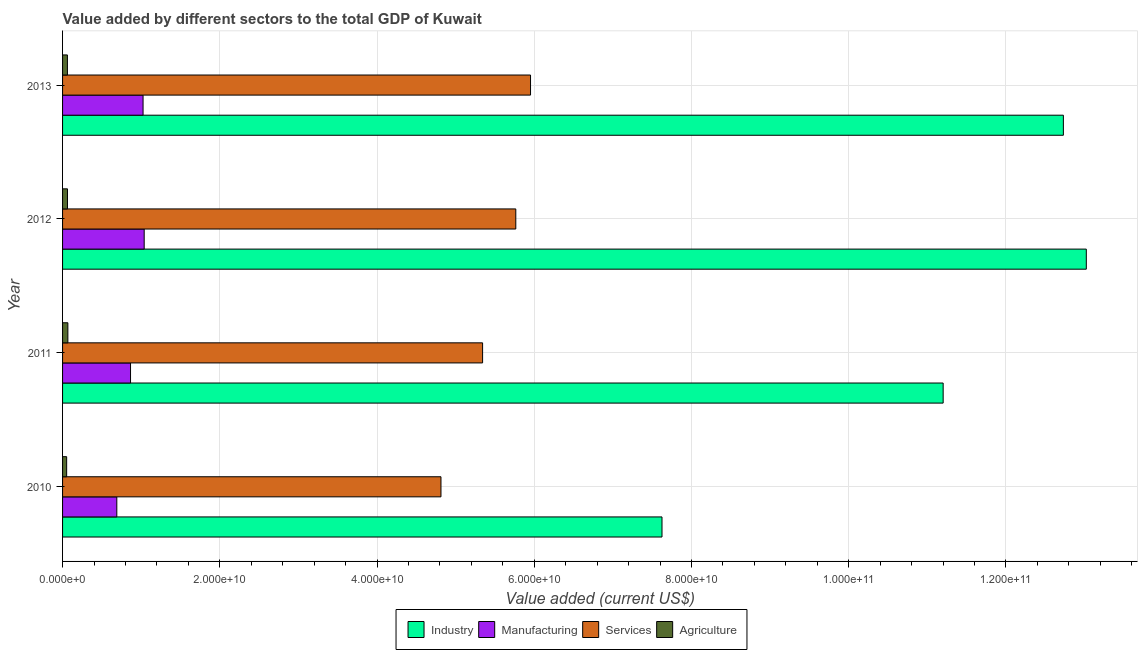How many bars are there on the 4th tick from the top?
Keep it short and to the point. 4. In how many cases, is the number of bars for a given year not equal to the number of legend labels?
Give a very brief answer. 0. What is the value added by manufacturing sector in 2011?
Keep it short and to the point. 8.65e+09. Across all years, what is the maximum value added by services sector?
Provide a succinct answer. 5.95e+1. Across all years, what is the minimum value added by agricultural sector?
Ensure brevity in your answer.  5.21e+08. In which year was the value added by industrial sector minimum?
Give a very brief answer. 2010. What is the total value added by industrial sector in the graph?
Your answer should be compact. 4.46e+11. What is the difference between the value added by manufacturing sector in 2011 and that in 2012?
Your answer should be very brief. -1.74e+09. What is the difference between the value added by industrial sector in 2010 and the value added by manufacturing sector in 2011?
Keep it short and to the point. 6.76e+1. What is the average value added by industrial sector per year?
Keep it short and to the point. 1.11e+11. In the year 2011, what is the difference between the value added by manufacturing sector and value added by agricultural sector?
Make the answer very short. 7.97e+09. What is the ratio of the value added by services sector in 2010 to that in 2011?
Provide a short and direct response. 0.9. Is the difference between the value added by services sector in 2010 and 2011 greater than the difference between the value added by agricultural sector in 2010 and 2011?
Your answer should be very brief. No. What is the difference between the highest and the second highest value added by manufacturing sector?
Offer a very short reply. 1.42e+08. What is the difference between the highest and the lowest value added by services sector?
Offer a terse response. 1.14e+1. In how many years, is the value added by agricultural sector greater than the average value added by agricultural sector taken over all years?
Your answer should be very brief. 3. Is the sum of the value added by manufacturing sector in 2010 and 2012 greater than the maximum value added by industrial sector across all years?
Give a very brief answer. No. Is it the case that in every year, the sum of the value added by services sector and value added by manufacturing sector is greater than the sum of value added by industrial sector and value added by agricultural sector?
Your answer should be compact. Yes. What does the 1st bar from the top in 2012 represents?
Your answer should be very brief. Agriculture. What does the 2nd bar from the bottom in 2013 represents?
Ensure brevity in your answer.  Manufacturing. Is it the case that in every year, the sum of the value added by industrial sector and value added by manufacturing sector is greater than the value added by services sector?
Give a very brief answer. Yes. Are all the bars in the graph horizontal?
Provide a succinct answer. Yes. How many years are there in the graph?
Ensure brevity in your answer.  4. What is the difference between two consecutive major ticks on the X-axis?
Provide a succinct answer. 2.00e+1. Are the values on the major ticks of X-axis written in scientific E-notation?
Offer a terse response. Yes. Where does the legend appear in the graph?
Keep it short and to the point. Bottom center. How many legend labels are there?
Your response must be concise. 4. How are the legend labels stacked?
Give a very brief answer. Horizontal. What is the title of the graph?
Give a very brief answer. Value added by different sectors to the total GDP of Kuwait. What is the label or title of the X-axis?
Ensure brevity in your answer.  Value added (current US$). What is the Value added (current US$) of Industry in 2010?
Your answer should be very brief. 7.63e+1. What is the Value added (current US$) in Manufacturing in 2010?
Your answer should be compact. 6.90e+09. What is the Value added (current US$) in Services in 2010?
Offer a terse response. 4.81e+1. What is the Value added (current US$) of Agriculture in 2010?
Your answer should be very brief. 5.21e+08. What is the Value added (current US$) in Industry in 2011?
Make the answer very short. 1.12e+11. What is the Value added (current US$) of Manufacturing in 2011?
Your answer should be very brief. 8.65e+09. What is the Value added (current US$) of Services in 2011?
Keep it short and to the point. 5.34e+1. What is the Value added (current US$) of Agriculture in 2011?
Offer a very short reply. 6.76e+08. What is the Value added (current US$) of Industry in 2012?
Give a very brief answer. 1.30e+11. What is the Value added (current US$) of Manufacturing in 2012?
Give a very brief answer. 1.04e+1. What is the Value added (current US$) of Services in 2012?
Give a very brief answer. 5.77e+1. What is the Value added (current US$) of Agriculture in 2012?
Make the answer very short. 6.26e+08. What is the Value added (current US$) in Industry in 2013?
Keep it short and to the point. 1.27e+11. What is the Value added (current US$) of Manufacturing in 2013?
Ensure brevity in your answer.  1.02e+1. What is the Value added (current US$) of Services in 2013?
Make the answer very short. 5.95e+1. What is the Value added (current US$) in Agriculture in 2013?
Ensure brevity in your answer.  6.18e+08. Across all years, what is the maximum Value added (current US$) in Industry?
Your answer should be compact. 1.30e+11. Across all years, what is the maximum Value added (current US$) in Manufacturing?
Provide a short and direct response. 1.04e+1. Across all years, what is the maximum Value added (current US$) of Services?
Your answer should be compact. 5.95e+1. Across all years, what is the maximum Value added (current US$) in Agriculture?
Offer a terse response. 6.76e+08. Across all years, what is the minimum Value added (current US$) of Industry?
Your answer should be compact. 7.63e+1. Across all years, what is the minimum Value added (current US$) in Manufacturing?
Offer a terse response. 6.90e+09. Across all years, what is the minimum Value added (current US$) of Services?
Offer a very short reply. 4.81e+1. Across all years, what is the minimum Value added (current US$) of Agriculture?
Keep it short and to the point. 5.21e+08. What is the total Value added (current US$) in Industry in the graph?
Give a very brief answer. 4.46e+11. What is the total Value added (current US$) in Manufacturing in the graph?
Provide a short and direct response. 3.62e+1. What is the total Value added (current US$) in Services in the graph?
Your answer should be very brief. 2.19e+11. What is the total Value added (current US$) in Agriculture in the graph?
Your answer should be compact. 2.44e+09. What is the difference between the Value added (current US$) of Industry in 2010 and that in 2011?
Your answer should be very brief. -3.58e+1. What is the difference between the Value added (current US$) of Manufacturing in 2010 and that in 2011?
Ensure brevity in your answer.  -1.75e+09. What is the difference between the Value added (current US$) of Services in 2010 and that in 2011?
Give a very brief answer. -5.29e+09. What is the difference between the Value added (current US$) in Agriculture in 2010 and that in 2011?
Provide a short and direct response. -1.55e+08. What is the difference between the Value added (current US$) of Industry in 2010 and that in 2012?
Provide a short and direct response. -5.40e+1. What is the difference between the Value added (current US$) of Manufacturing in 2010 and that in 2012?
Make the answer very short. -3.48e+09. What is the difference between the Value added (current US$) of Services in 2010 and that in 2012?
Your answer should be very brief. -9.52e+09. What is the difference between the Value added (current US$) of Agriculture in 2010 and that in 2012?
Ensure brevity in your answer.  -1.05e+08. What is the difference between the Value added (current US$) in Industry in 2010 and that in 2013?
Keep it short and to the point. -5.11e+1. What is the difference between the Value added (current US$) of Manufacturing in 2010 and that in 2013?
Your answer should be compact. -3.34e+09. What is the difference between the Value added (current US$) in Services in 2010 and that in 2013?
Offer a very short reply. -1.14e+1. What is the difference between the Value added (current US$) of Agriculture in 2010 and that in 2013?
Offer a terse response. -9.72e+07. What is the difference between the Value added (current US$) of Industry in 2011 and that in 2012?
Ensure brevity in your answer.  -1.82e+1. What is the difference between the Value added (current US$) of Manufacturing in 2011 and that in 2012?
Provide a short and direct response. -1.74e+09. What is the difference between the Value added (current US$) in Services in 2011 and that in 2012?
Your answer should be compact. -4.22e+09. What is the difference between the Value added (current US$) of Agriculture in 2011 and that in 2012?
Your response must be concise. 4.98e+07. What is the difference between the Value added (current US$) in Industry in 2011 and that in 2013?
Your response must be concise. -1.53e+1. What is the difference between the Value added (current US$) of Manufacturing in 2011 and that in 2013?
Make the answer very short. -1.59e+09. What is the difference between the Value added (current US$) of Services in 2011 and that in 2013?
Provide a succinct answer. -6.10e+09. What is the difference between the Value added (current US$) of Agriculture in 2011 and that in 2013?
Your response must be concise. 5.76e+07. What is the difference between the Value added (current US$) of Industry in 2012 and that in 2013?
Keep it short and to the point. 2.92e+09. What is the difference between the Value added (current US$) in Manufacturing in 2012 and that in 2013?
Make the answer very short. 1.42e+08. What is the difference between the Value added (current US$) of Services in 2012 and that in 2013?
Offer a very short reply. -1.87e+09. What is the difference between the Value added (current US$) in Agriculture in 2012 and that in 2013?
Offer a very short reply. 7.82e+06. What is the difference between the Value added (current US$) of Industry in 2010 and the Value added (current US$) of Manufacturing in 2011?
Make the answer very short. 6.76e+1. What is the difference between the Value added (current US$) in Industry in 2010 and the Value added (current US$) in Services in 2011?
Ensure brevity in your answer.  2.28e+1. What is the difference between the Value added (current US$) in Industry in 2010 and the Value added (current US$) in Agriculture in 2011?
Your answer should be very brief. 7.56e+1. What is the difference between the Value added (current US$) in Manufacturing in 2010 and the Value added (current US$) in Services in 2011?
Offer a very short reply. -4.65e+1. What is the difference between the Value added (current US$) of Manufacturing in 2010 and the Value added (current US$) of Agriculture in 2011?
Offer a terse response. 6.22e+09. What is the difference between the Value added (current US$) in Services in 2010 and the Value added (current US$) in Agriculture in 2011?
Give a very brief answer. 4.75e+1. What is the difference between the Value added (current US$) in Industry in 2010 and the Value added (current US$) in Manufacturing in 2012?
Your answer should be compact. 6.59e+1. What is the difference between the Value added (current US$) in Industry in 2010 and the Value added (current US$) in Services in 2012?
Make the answer very short. 1.86e+1. What is the difference between the Value added (current US$) in Industry in 2010 and the Value added (current US$) in Agriculture in 2012?
Your response must be concise. 7.56e+1. What is the difference between the Value added (current US$) of Manufacturing in 2010 and the Value added (current US$) of Services in 2012?
Your answer should be very brief. -5.08e+1. What is the difference between the Value added (current US$) in Manufacturing in 2010 and the Value added (current US$) in Agriculture in 2012?
Make the answer very short. 6.27e+09. What is the difference between the Value added (current US$) in Services in 2010 and the Value added (current US$) in Agriculture in 2012?
Keep it short and to the point. 4.75e+1. What is the difference between the Value added (current US$) in Industry in 2010 and the Value added (current US$) in Manufacturing in 2013?
Your answer should be compact. 6.60e+1. What is the difference between the Value added (current US$) in Industry in 2010 and the Value added (current US$) in Services in 2013?
Offer a very short reply. 1.67e+1. What is the difference between the Value added (current US$) of Industry in 2010 and the Value added (current US$) of Agriculture in 2013?
Make the answer very short. 7.56e+1. What is the difference between the Value added (current US$) in Manufacturing in 2010 and the Value added (current US$) in Services in 2013?
Offer a terse response. -5.26e+1. What is the difference between the Value added (current US$) of Manufacturing in 2010 and the Value added (current US$) of Agriculture in 2013?
Provide a succinct answer. 6.28e+09. What is the difference between the Value added (current US$) in Services in 2010 and the Value added (current US$) in Agriculture in 2013?
Ensure brevity in your answer.  4.75e+1. What is the difference between the Value added (current US$) of Industry in 2011 and the Value added (current US$) of Manufacturing in 2012?
Your response must be concise. 1.02e+11. What is the difference between the Value added (current US$) of Industry in 2011 and the Value added (current US$) of Services in 2012?
Offer a very short reply. 5.44e+1. What is the difference between the Value added (current US$) in Industry in 2011 and the Value added (current US$) in Agriculture in 2012?
Keep it short and to the point. 1.11e+11. What is the difference between the Value added (current US$) of Manufacturing in 2011 and the Value added (current US$) of Services in 2012?
Keep it short and to the point. -4.90e+1. What is the difference between the Value added (current US$) of Manufacturing in 2011 and the Value added (current US$) of Agriculture in 2012?
Provide a succinct answer. 8.02e+09. What is the difference between the Value added (current US$) in Services in 2011 and the Value added (current US$) in Agriculture in 2012?
Your response must be concise. 5.28e+1. What is the difference between the Value added (current US$) of Industry in 2011 and the Value added (current US$) of Manufacturing in 2013?
Ensure brevity in your answer.  1.02e+11. What is the difference between the Value added (current US$) of Industry in 2011 and the Value added (current US$) of Services in 2013?
Offer a very short reply. 5.25e+1. What is the difference between the Value added (current US$) of Industry in 2011 and the Value added (current US$) of Agriculture in 2013?
Your response must be concise. 1.11e+11. What is the difference between the Value added (current US$) of Manufacturing in 2011 and the Value added (current US$) of Services in 2013?
Ensure brevity in your answer.  -5.09e+1. What is the difference between the Value added (current US$) of Manufacturing in 2011 and the Value added (current US$) of Agriculture in 2013?
Give a very brief answer. 8.03e+09. What is the difference between the Value added (current US$) in Services in 2011 and the Value added (current US$) in Agriculture in 2013?
Give a very brief answer. 5.28e+1. What is the difference between the Value added (current US$) in Industry in 2012 and the Value added (current US$) in Manufacturing in 2013?
Your answer should be compact. 1.20e+11. What is the difference between the Value added (current US$) of Industry in 2012 and the Value added (current US$) of Services in 2013?
Make the answer very short. 7.07e+1. What is the difference between the Value added (current US$) of Industry in 2012 and the Value added (current US$) of Agriculture in 2013?
Provide a short and direct response. 1.30e+11. What is the difference between the Value added (current US$) of Manufacturing in 2012 and the Value added (current US$) of Services in 2013?
Give a very brief answer. -4.91e+1. What is the difference between the Value added (current US$) of Manufacturing in 2012 and the Value added (current US$) of Agriculture in 2013?
Offer a very short reply. 9.76e+09. What is the difference between the Value added (current US$) of Services in 2012 and the Value added (current US$) of Agriculture in 2013?
Offer a terse response. 5.70e+1. What is the average Value added (current US$) of Industry per year?
Keep it short and to the point. 1.11e+11. What is the average Value added (current US$) of Manufacturing per year?
Ensure brevity in your answer.  9.04e+09. What is the average Value added (current US$) of Services per year?
Give a very brief answer. 5.47e+1. What is the average Value added (current US$) of Agriculture per year?
Provide a short and direct response. 6.11e+08. In the year 2010, what is the difference between the Value added (current US$) of Industry and Value added (current US$) of Manufacturing?
Offer a very short reply. 6.94e+1. In the year 2010, what is the difference between the Value added (current US$) in Industry and Value added (current US$) in Services?
Your answer should be very brief. 2.81e+1. In the year 2010, what is the difference between the Value added (current US$) in Industry and Value added (current US$) in Agriculture?
Provide a succinct answer. 7.57e+1. In the year 2010, what is the difference between the Value added (current US$) of Manufacturing and Value added (current US$) of Services?
Offer a terse response. -4.12e+1. In the year 2010, what is the difference between the Value added (current US$) of Manufacturing and Value added (current US$) of Agriculture?
Offer a terse response. 6.38e+09. In the year 2010, what is the difference between the Value added (current US$) of Services and Value added (current US$) of Agriculture?
Your response must be concise. 4.76e+1. In the year 2011, what is the difference between the Value added (current US$) in Industry and Value added (current US$) in Manufacturing?
Ensure brevity in your answer.  1.03e+11. In the year 2011, what is the difference between the Value added (current US$) in Industry and Value added (current US$) in Services?
Ensure brevity in your answer.  5.86e+1. In the year 2011, what is the difference between the Value added (current US$) of Industry and Value added (current US$) of Agriculture?
Give a very brief answer. 1.11e+11. In the year 2011, what is the difference between the Value added (current US$) of Manufacturing and Value added (current US$) of Services?
Your answer should be very brief. -4.48e+1. In the year 2011, what is the difference between the Value added (current US$) in Manufacturing and Value added (current US$) in Agriculture?
Keep it short and to the point. 7.97e+09. In the year 2011, what is the difference between the Value added (current US$) in Services and Value added (current US$) in Agriculture?
Ensure brevity in your answer.  5.28e+1. In the year 2012, what is the difference between the Value added (current US$) of Industry and Value added (current US$) of Manufacturing?
Your answer should be compact. 1.20e+11. In the year 2012, what is the difference between the Value added (current US$) of Industry and Value added (current US$) of Services?
Give a very brief answer. 7.26e+1. In the year 2012, what is the difference between the Value added (current US$) in Industry and Value added (current US$) in Agriculture?
Keep it short and to the point. 1.30e+11. In the year 2012, what is the difference between the Value added (current US$) in Manufacturing and Value added (current US$) in Services?
Offer a terse response. -4.73e+1. In the year 2012, what is the difference between the Value added (current US$) of Manufacturing and Value added (current US$) of Agriculture?
Offer a terse response. 9.76e+09. In the year 2012, what is the difference between the Value added (current US$) of Services and Value added (current US$) of Agriculture?
Ensure brevity in your answer.  5.70e+1. In the year 2013, what is the difference between the Value added (current US$) of Industry and Value added (current US$) of Manufacturing?
Make the answer very short. 1.17e+11. In the year 2013, what is the difference between the Value added (current US$) of Industry and Value added (current US$) of Services?
Ensure brevity in your answer.  6.78e+1. In the year 2013, what is the difference between the Value added (current US$) in Industry and Value added (current US$) in Agriculture?
Make the answer very short. 1.27e+11. In the year 2013, what is the difference between the Value added (current US$) in Manufacturing and Value added (current US$) in Services?
Offer a very short reply. -4.93e+1. In the year 2013, what is the difference between the Value added (current US$) of Manufacturing and Value added (current US$) of Agriculture?
Offer a very short reply. 9.62e+09. In the year 2013, what is the difference between the Value added (current US$) of Services and Value added (current US$) of Agriculture?
Provide a short and direct response. 5.89e+1. What is the ratio of the Value added (current US$) in Industry in 2010 to that in 2011?
Offer a terse response. 0.68. What is the ratio of the Value added (current US$) of Manufacturing in 2010 to that in 2011?
Keep it short and to the point. 0.8. What is the ratio of the Value added (current US$) of Services in 2010 to that in 2011?
Your response must be concise. 0.9. What is the ratio of the Value added (current US$) in Agriculture in 2010 to that in 2011?
Your response must be concise. 0.77. What is the ratio of the Value added (current US$) in Industry in 2010 to that in 2012?
Provide a short and direct response. 0.59. What is the ratio of the Value added (current US$) of Manufacturing in 2010 to that in 2012?
Keep it short and to the point. 0.66. What is the ratio of the Value added (current US$) of Services in 2010 to that in 2012?
Give a very brief answer. 0.83. What is the ratio of the Value added (current US$) in Agriculture in 2010 to that in 2012?
Provide a short and direct response. 0.83. What is the ratio of the Value added (current US$) in Industry in 2010 to that in 2013?
Your answer should be very brief. 0.6. What is the ratio of the Value added (current US$) of Manufacturing in 2010 to that in 2013?
Ensure brevity in your answer.  0.67. What is the ratio of the Value added (current US$) in Services in 2010 to that in 2013?
Make the answer very short. 0.81. What is the ratio of the Value added (current US$) in Agriculture in 2010 to that in 2013?
Make the answer very short. 0.84. What is the ratio of the Value added (current US$) in Industry in 2011 to that in 2012?
Ensure brevity in your answer.  0.86. What is the ratio of the Value added (current US$) in Manufacturing in 2011 to that in 2012?
Ensure brevity in your answer.  0.83. What is the ratio of the Value added (current US$) of Services in 2011 to that in 2012?
Make the answer very short. 0.93. What is the ratio of the Value added (current US$) in Agriculture in 2011 to that in 2012?
Provide a short and direct response. 1.08. What is the ratio of the Value added (current US$) in Industry in 2011 to that in 2013?
Ensure brevity in your answer.  0.88. What is the ratio of the Value added (current US$) of Manufacturing in 2011 to that in 2013?
Provide a succinct answer. 0.84. What is the ratio of the Value added (current US$) of Services in 2011 to that in 2013?
Your answer should be very brief. 0.9. What is the ratio of the Value added (current US$) of Agriculture in 2011 to that in 2013?
Offer a terse response. 1.09. What is the ratio of the Value added (current US$) of Industry in 2012 to that in 2013?
Your answer should be compact. 1.02. What is the ratio of the Value added (current US$) in Manufacturing in 2012 to that in 2013?
Your response must be concise. 1.01. What is the ratio of the Value added (current US$) of Services in 2012 to that in 2013?
Offer a terse response. 0.97. What is the ratio of the Value added (current US$) of Agriculture in 2012 to that in 2013?
Offer a terse response. 1.01. What is the difference between the highest and the second highest Value added (current US$) of Industry?
Offer a very short reply. 2.92e+09. What is the difference between the highest and the second highest Value added (current US$) of Manufacturing?
Your answer should be compact. 1.42e+08. What is the difference between the highest and the second highest Value added (current US$) in Services?
Offer a terse response. 1.87e+09. What is the difference between the highest and the second highest Value added (current US$) of Agriculture?
Provide a short and direct response. 4.98e+07. What is the difference between the highest and the lowest Value added (current US$) of Industry?
Offer a very short reply. 5.40e+1. What is the difference between the highest and the lowest Value added (current US$) in Manufacturing?
Provide a succinct answer. 3.48e+09. What is the difference between the highest and the lowest Value added (current US$) of Services?
Offer a very short reply. 1.14e+1. What is the difference between the highest and the lowest Value added (current US$) in Agriculture?
Make the answer very short. 1.55e+08. 